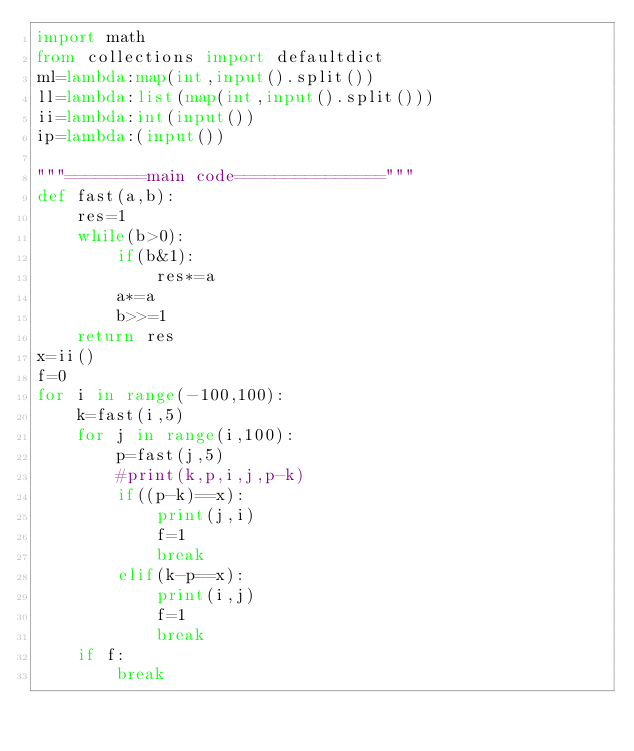Convert code to text. <code><loc_0><loc_0><loc_500><loc_500><_Python_>import math
from collections import defaultdict
ml=lambda:map(int,input().split())
ll=lambda:list(map(int,input().split()))
ii=lambda:int(input())
ip=lambda:(input())

"""========main code==============="""
def fast(a,b):
    res=1
    while(b>0):
        if(b&1):
            res*=a
        a*=a    
        b>>=1
    return res
x=ii()
f=0
for i in range(-100,100):
    k=fast(i,5)
    for j in range(i,100):
        p=fast(j,5)
        #print(k,p,i,j,p-k)
        if((p-k)==x):
            print(j,i)
            f=1
            break
        elif(k-p==x):
            print(i,j)
            f=1
            break
    if f:
        break
</code> 